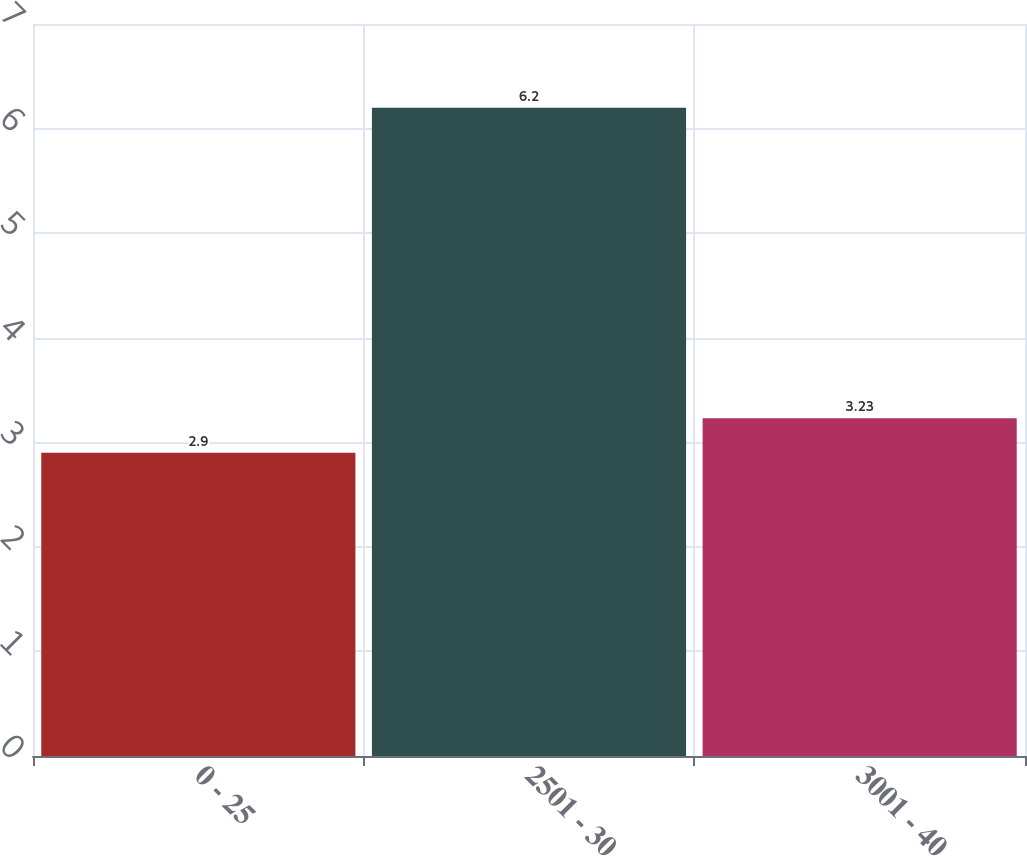Convert chart. <chart><loc_0><loc_0><loc_500><loc_500><bar_chart><fcel>0 - 25<fcel>2501 - 30<fcel>3001 - 40<nl><fcel>2.9<fcel>6.2<fcel>3.23<nl></chart> 